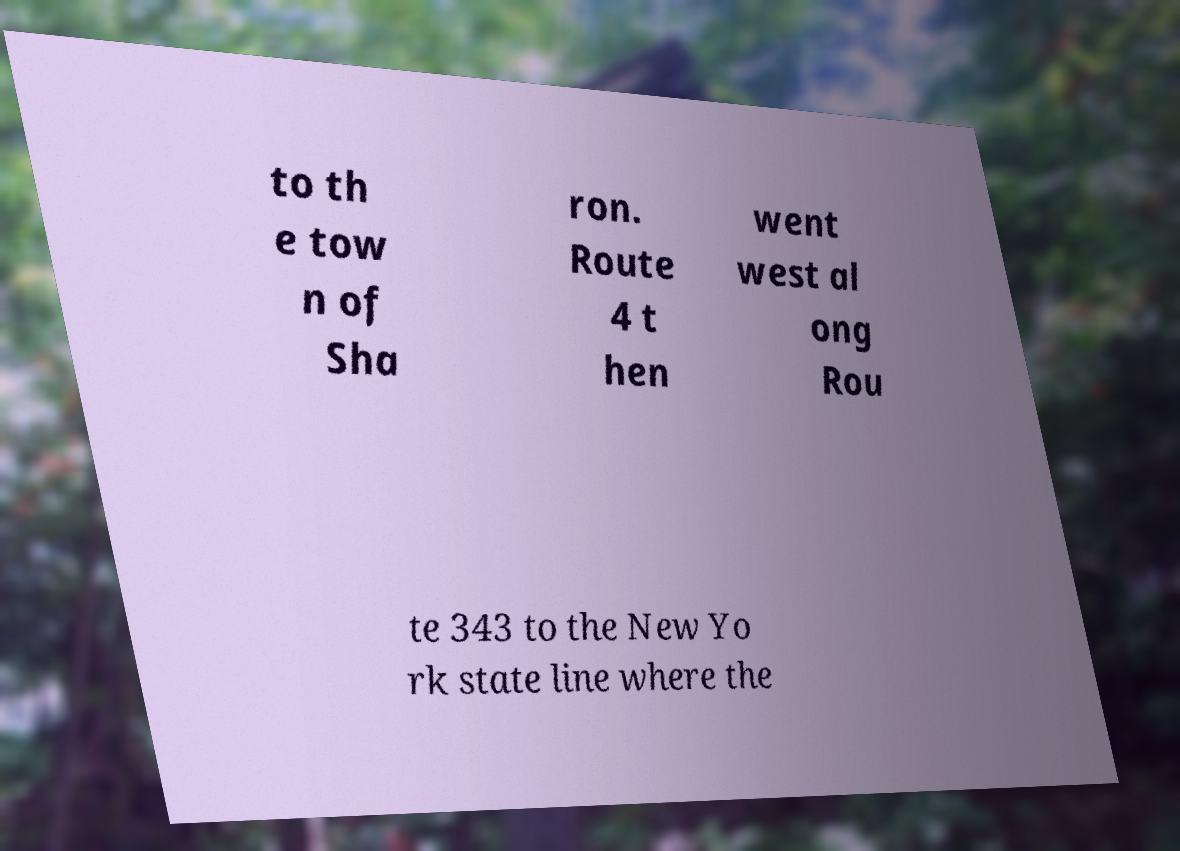For documentation purposes, I need the text within this image transcribed. Could you provide that? to th e tow n of Sha ron. Route 4 t hen went west al ong Rou te 343 to the New Yo rk state line where the 